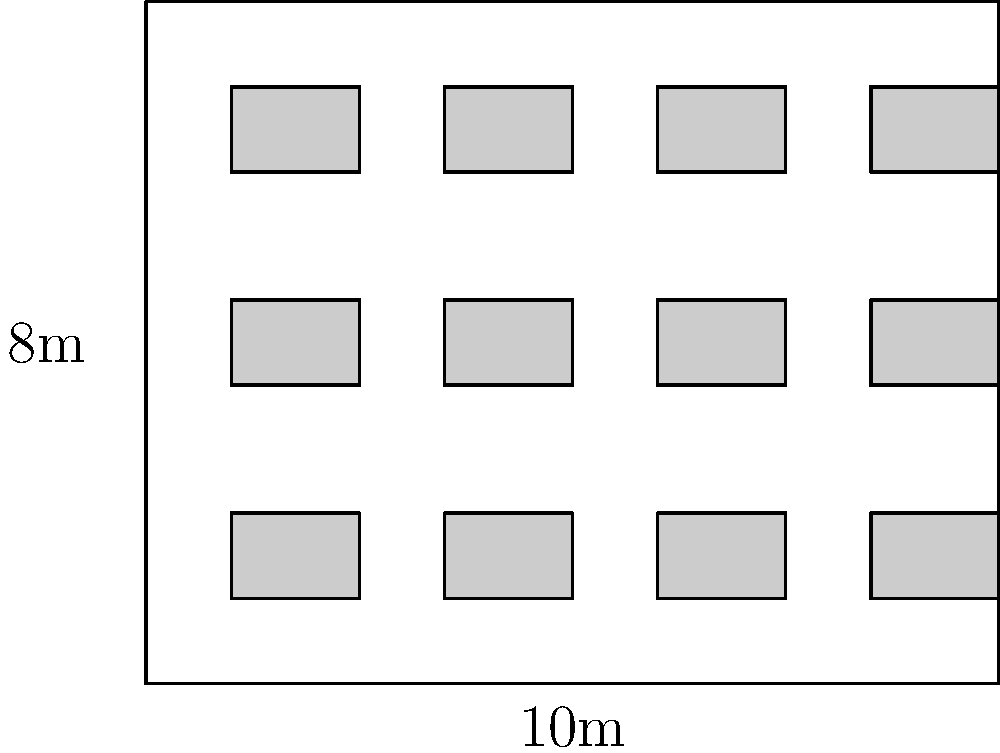Given the office layout shown above, where each desk occupies a 1.5m x 1m area, what is the maximum number of desks that can be fitted into this space while maintaining a minimum 0.5m gap between desks and walls? To maximize worker density while maintaining the required gaps, we need to follow these steps:

1. Calculate the usable space:
   - Office dimensions: 10m x 8m
   - Subtracting 0.5m gaps on all sides: 9m x 7m usable space

2. Determine the space needed for each desk unit:
   - Desk size: 1.5m x 1m
   - Adding 0.5m gap on two sides: 2m x 1.5m per desk unit

3. Calculate the number of desks that can fit in each direction:
   - Horizontally: $\lfloor 9\text{m} \div 2\text{m} \rfloor = 4$ desks
   - Vertically: $\lfloor 7\text{m} \div 1.5\text{m} \rfloor = 4$ desks

4. Multiply to get the total number of desks:
   $4 \times 4 = 16$ desks

Therefore, the maximum number of desks that can be fitted into this office space while maintaining the required gaps is 16.
Answer: 16 desks 